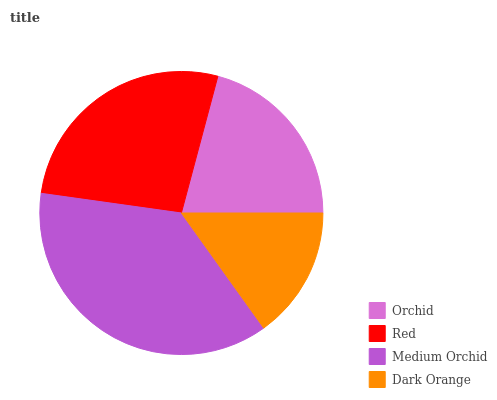Is Dark Orange the minimum?
Answer yes or no. Yes. Is Medium Orchid the maximum?
Answer yes or no. Yes. Is Red the minimum?
Answer yes or no. No. Is Red the maximum?
Answer yes or no. No. Is Red greater than Orchid?
Answer yes or no. Yes. Is Orchid less than Red?
Answer yes or no. Yes. Is Orchid greater than Red?
Answer yes or no. No. Is Red less than Orchid?
Answer yes or no. No. Is Red the high median?
Answer yes or no. Yes. Is Orchid the low median?
Answer yes or no. Yes. Is Dark Orange the high median?
Answer yes or no. No. Is Dark Orange the low median?
Answer yes or no. No. 